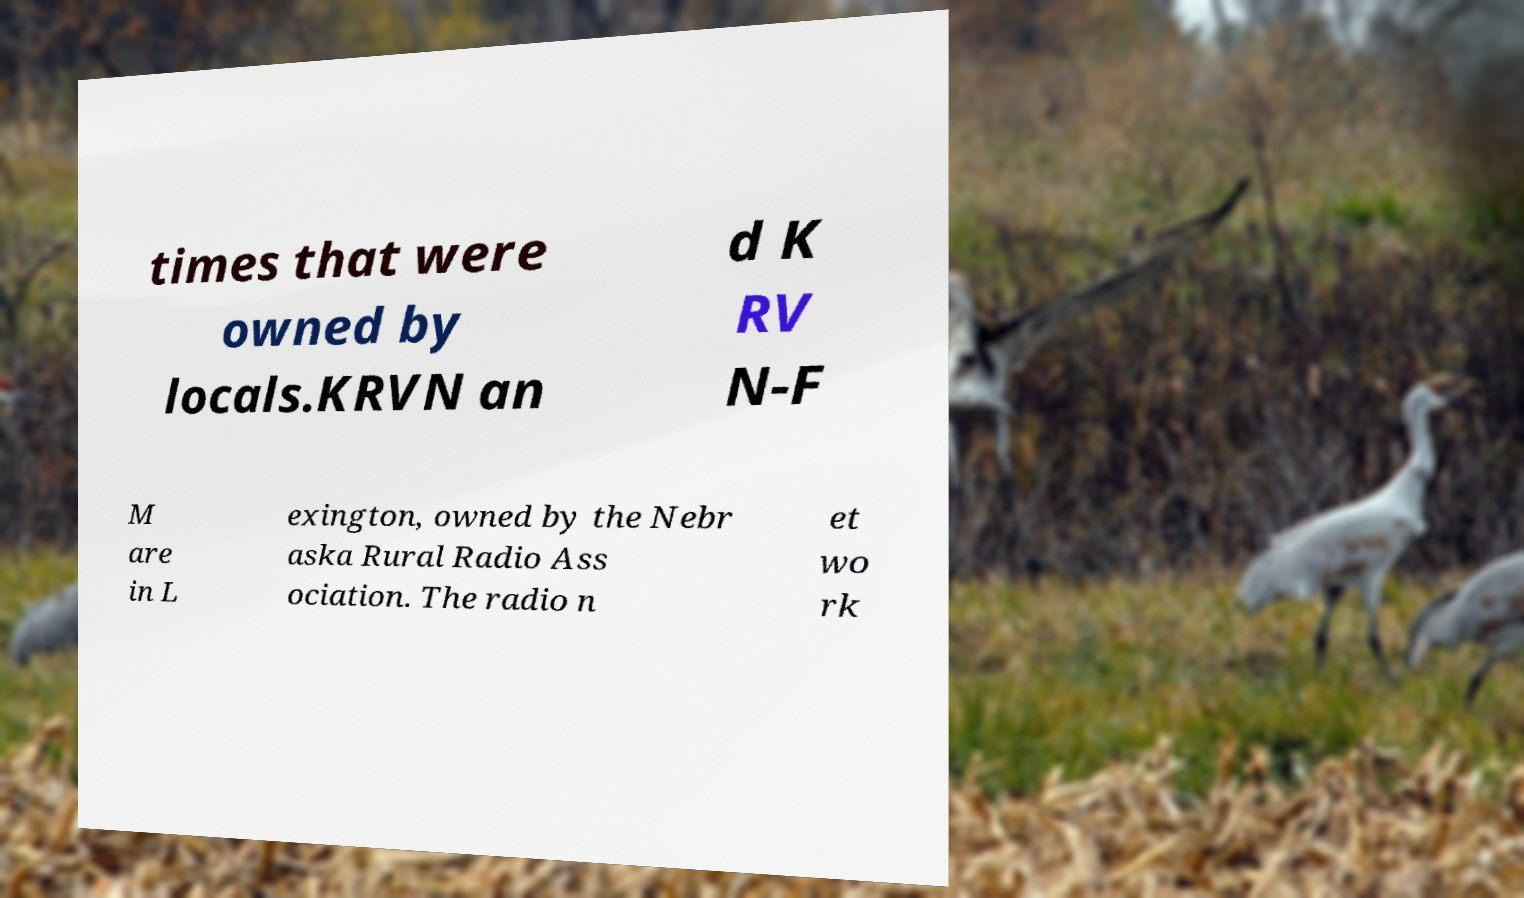Could you assist in decoding the text presented in this image and type it out clearly? times that were owned by locals.KRVN an d K RV N-F M are in L exington, owned by the Nebr aska Rural Radio Ass ociation. The radio n et wo rk 